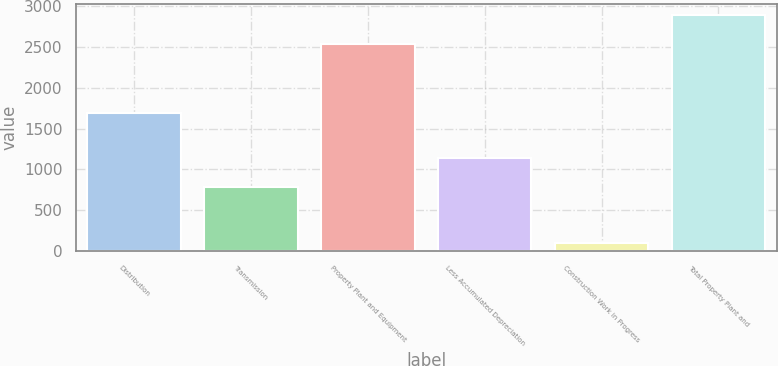<chart> <loc_0><loc_0><loc_500><loc_500><bar_chart><fcel>Distribution<fcel>Transmission<fcel>Property Plant and Equipment<fcel>Less Accumulated Depreciation<fcel>Construction Work in Progress<fcel>Total Property Plant and<nl><fcel>1696.7<fcel>789.7<fcel>2532.9<fcel>1141.7<fcel>102.9<fcel>2884.9<nl></chart> 